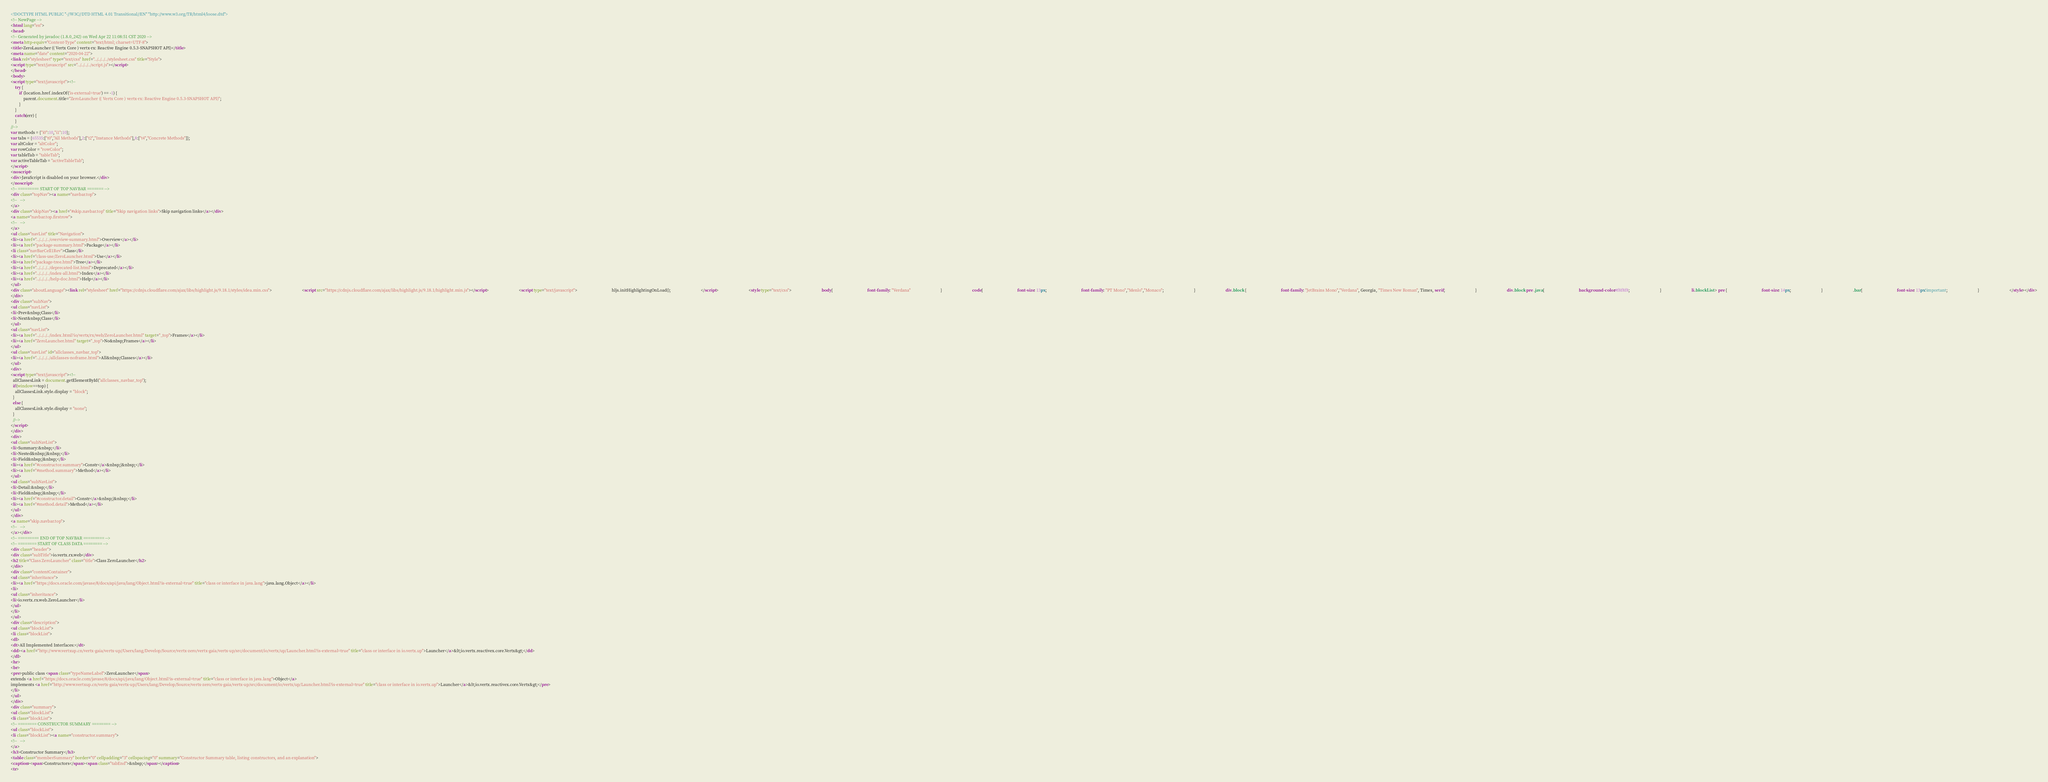<code> <loc_0><loc_0><loc_500><loc_500><_HTML_><!DOCTYPE HTML PUBLIC "-//W3C//DTD HTML 4.01 Transitional//EN" "http://www.w3.org/TR/html4/loose.dtd">
<!-- NewPage -->
<html lang="en">
<head>
<!-- Generated by javadoc (1.8.0_242) on Wed Apr 22 11:08:51 CST 2020 -->
<meta http-equiv="Content-Type" content="text/html; charset=UTF-8">
<title>ZeroLauncher (( Vertx Core ) vertx-rx: Reactive Engine 0.5.3-SNAPSHOT API)</title>
<meta name="date" content="2020-04-22">
<link rel="stylesheet" type="text/css" href="../../../../stylesheet.css" title="Style">
<script type="text/javascript" src="../../../../script.js"></script>
</head>
<body>
<script type="text/javascript"><!--
    try {
        if (location.href.indexOf('is-external=true') == -1) {
            parent.document.title="ZeroLauncher (( Vertx Core ) vertx-rx: Reactive Engine 0.5.3-SNAPSHOT API)";
        }
    }
    catch(err) {
    }
//-->
var methods = {"i0":10,"i1":10};
var tabs = {65535:["t0","All Methods"],2:["t2","Instance Methods"],8:["t4","Concrete Methods"]};
var altColor = "altColor";
var rowColor = "rowColor";
var tableTab = "tableTab";
var activeTableTab = "activeTableTab";
</script>
<noscript>
<div>JavaScript is disabled on your browser.</div>
</noscript>
<!-- ========= START OF TOP NAVBAR ======= -->
<div class="topNav"><a name="navbar.top">
<!--   -->
</a>
<div class="skipNav"><a href="#skip.navbar.top" title="Skip navigation links">Skip navigation links</a></div>
<a name="navbar.top.firstrow">
<!--   -->
</a>
<ul class="navList" title="Navigation">
<li><a href="../../../../overview-summary.html">Overview</a></li>
<li><a href="package-summary.html">Package</a></li>
<li class="navBarCell1Rev">Class</li>
<li><a href="class-use/ZeroLauncher.html">Use</a></li>
<li><a href="package-tree.html">Tree</a></li>
<li><a href="../../../../deprecated-list.html">Deprecated</a></li>
<li><a href="../../../../index-all.html">Index</a></li>
<li><a href="../../../../help-doc.html">Help</a></li>
</ul>
<div class="aboutLanguage"><link rel="stylesheet" href="https://cdnjs.cloudflare.com/ajax/libs/highlight.js/9.18.1/styles/idea.min.css">                             <script src="https://cdnjs.cloudflare.com/ajax/libs/highlight.js/9.18.1/highlight.min.js"></script>                             <script type="text/javascript">                                 hljs.initHighlightingOnLoad();                             </script>                             <style type="text/css">                             body{                                 font-family: "Verdana"                             }                             code{                                 font-size: 13px;                                 font-family: "PT Mono","Menlo","Monaco";                             }                             div.block {                                 font-family: "JetBrains Mono","Verdana", Georgia, "Times New Roman", Times, serif;                             }                             div.block pre .java{                                 background-color:#f8f8f8;                             }                             li.blockList > pre {                                 font-size: 14px;                             }                             .bar{                                 font-size: 13px!important;                             }                             </style></div>
</div>
<div class="subNav">
<ul class="navList">
<li>Prev&nbsp;Class</li>
<li>Next&nbsp;Class</li>
</ul>
<ul class="navList">
<li><a href="../../../../index.html?io/vertx/rx/web/ZeroLauncher.html" target="_top">Frames</a></li>
<li><a href="ZeroLauncher.html" target="_top">No&nbsp;Frames</a></li>
</ul>
<ul class="navList" id="allclasses_navbar_top">
<li><a href="../../../../allclasses-noframe.html">All&nbsp;Classes</a></li>
</ul>
<div>
<script type="text/javascript"><!--
  allClassesLink = document.getElementById("allclasses_navbar_top");
  if(window==top) {
    allClassesLink.style.display = "block";
  }
  else {
    allClassesLink.style.display = "none";
  }
  //-->
</script>
</div>
<div>
<ul class="subNavList">
<li>Summary:&nbsp;</li>
<li>Nested&nbsp;|&nbsp;</li>
<li>Field&nbsp;|&nbsp;</li>
<li><a href="#constructor.summary">Constr</a>&nbsp;|&nbsp;</li>
<li><a href="#method.summary">Method</a></li>
</ul>
<ul class="subNavList">
<li>Detail:&nbsp;</li>
<li>Field&nbsp;|&nbsp;</li>
<li><a href="#constructor.detail">Constr</a>&nbsp;|&nbsp;</li>
<li><a href="#method.detail">Method</a></li>
</ul>
</div>
<a name="skip.navbar.top">
<!--   -->
</a></div>
<!-- ========= END OF TOP NAVBAR ========= -->
<!-- ======== START OF CLASS DATA ======== -->
<div class="header">
<div class="subTitle">io.vertx.rx.web</div>
<h2 title="Class ZeroLauncher" class="title">Class ZeroLauncher</h2>
</div>
<div class="contentContainer">
<ul class="inheritance">
<li><a href="https://docs.oracle.com/javase/8/docs/api/java/lang/Object.html?is-external=true" title="class or interface in java.lang">java.lang.Object</a></li>
<li>
<ul class="inheritance">
<li>io.vertx.rx.web.ZeroLauncher</li>
</ul>
</li>
</ul>
<div class="description">
<ul class="blockList">
<li class="blockList">
<dl>
<dt>All Implemented Interfaces:</dt>
<dd><a href="http://www.vertxup.cn/vertx-gaia/vertx-up//Users/lang/Develop/Source/vertx-zero/vertx-gaia/vertx-up/src/document/io/vertx/up/Launcher.html?is-external=true" title="class or interface in io.vertx.up">Launcher</a>&lt;io.vertx.reactivex.core.Vertx&gt;</dd>
</dl>
<hr>
<br>
<pre>public class <span class="typeNameLabel">ZeroLauncher</span>
extends <a href="https://docs.oracle.com/javase/8/docs/api/java/lang/Object.html?is-external=true" title="class or interface in java.lang">Object</a>
implements <a href="http://www.vertxup.cn/vertx-gaia/vertx-up//Users/lang/Develop/Source/vertx-zero/vertx-gaia/vertx-up/src/document/io/vertx/up/Launcher.html?is-external=true" title="class or interface in io.vertx.up">Launcher</a>&lt;io.vertx.reactivex.core.Vertx&gt;</pre>
</li>
</ul>
</div>
<div class="summary">
<ul class="blockList">
<li class="blockList">
<!-- ======== CONSTRUCTOR SUMMARY ======== -->
<ul class="blockList">
<li class="blockList"><a name="constructor.summary">
<!--   -->
</a>
<h3>Constructor Summary</h3>
<table class="memberSummary" border="0" cellpadding="3" cellspacing="0" summary="Constructor Summary table, listing constructors, and an explanation">
<caption><span>Constructors</span><span class="tabEnd">&nbsp;</span></caption>
<tr></code> 